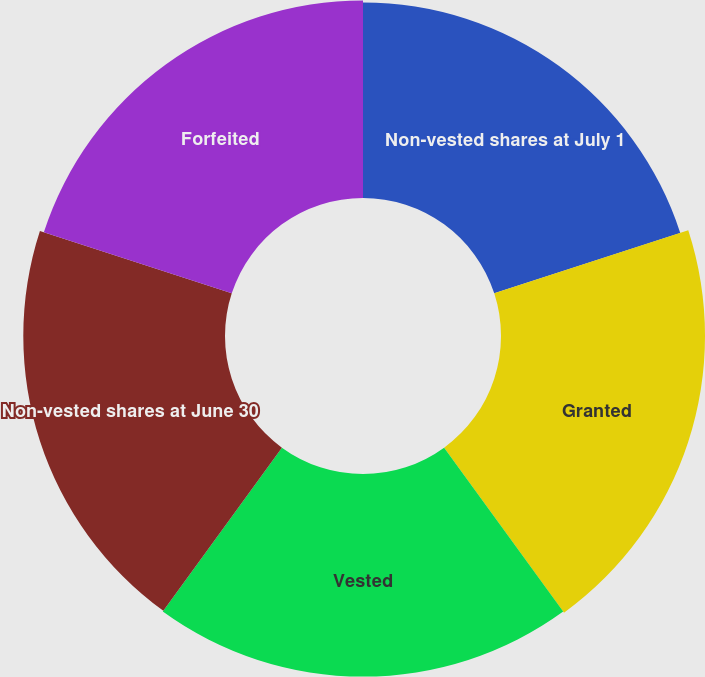<chart> <loc_0><loc_0><loc_500><loc_500><pie_chart><fcel>Non-vested shares at July 1<fcel>Granted<fcel>Vested<fcel>Non-vested shares at June 30<fcel>Forfeited<nl><fcel>19.53%<fcel>20.37%<fcel>20.23%<fcel>20.14%<fcel>19.73%<nl></chart> 